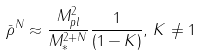<formula> <loc_0><loc_0><loc_500><loc_500>\bar { \rho } ^ { N } \approx \frac { M _ { p l } ^ { 2 } } { M _ { \ast } ^ { 2 + N } } \frac { 1 } { ( 1 - K ) } , \, K \neq 1</formula> 